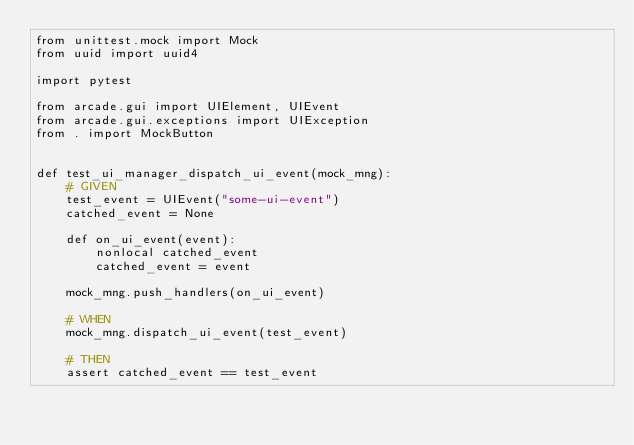Convert code to text. <code><loc_0><loc_0><loc_500><loc_500><_Python_>from unittest.mock import Mock
from uuid import uuid4

import pytest

from arcade.gui import UIElement, UIEvent
from arcade.gui.exceptions import UIException
from . import MockButton


def test_ui_manager_dispatch_ui_event(mock_mng):
    # GIVEN
    test_event = UIEvent("some-ui-event")
    catched_event = None

    def on_ui_event(event):
        nonlocal catched_event
        catched_event = event

    mock_mng.push_handlers(on_ui_event)

    # WHEN
    mock_mng.dispatch_ui_event(test_event)

    # THEN
    assert catched_event == test_event

</code> 